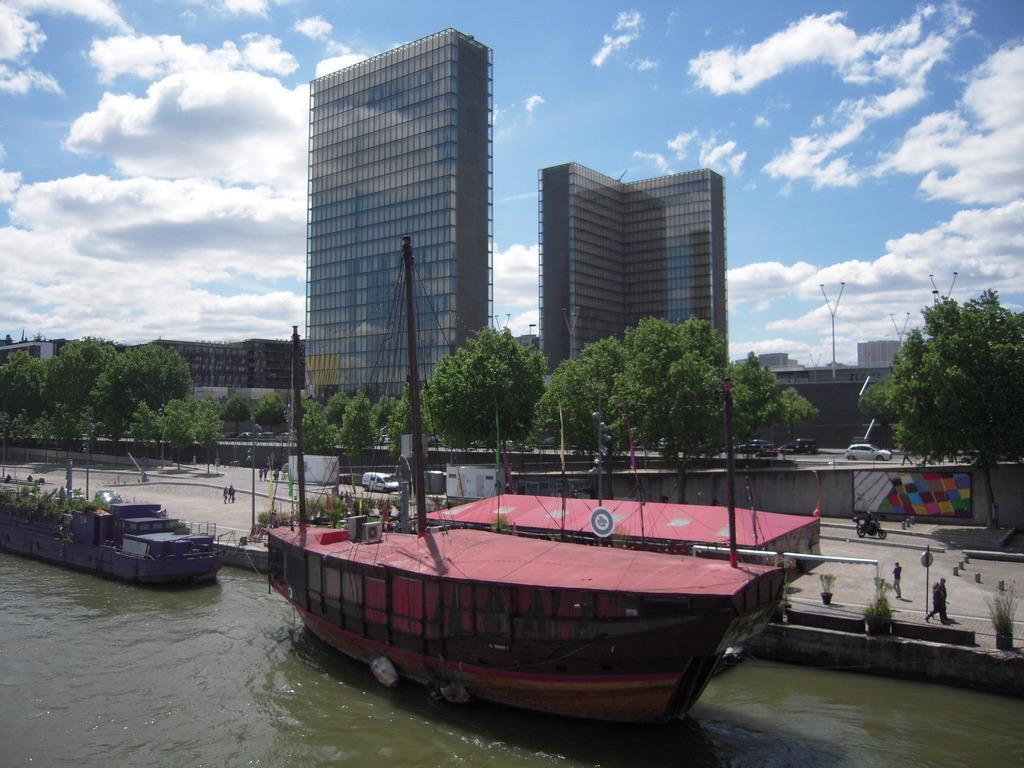Can you describe this image briefly? In this image I can see the water and few boats on the surface of the water. I can see the ground, few persons, few vehicles, few trees which are green in color, few poles and few buildings. In the background I can see the sky. 